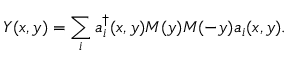Convert formula to latex. <formula><loc_0><loc_0><loc_500><loc_500>Y ( x , y ) = \sum _ { i } a _ { i } ^ { \dagger } ( x , y ) M ( y ) M ( - y ) a _ { i } ( x , y ) .</formula> 